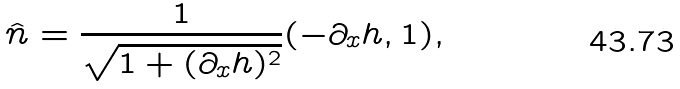<formula> <loc_0><loc_0><loc_500><loc_500>\hat { n } = \frac { 1 } { \sqrt { 1 + ( \partial _ { x } h ) ^ { 2 } } } ( - \partial _ { x } h , 1 ) ,</formula> 